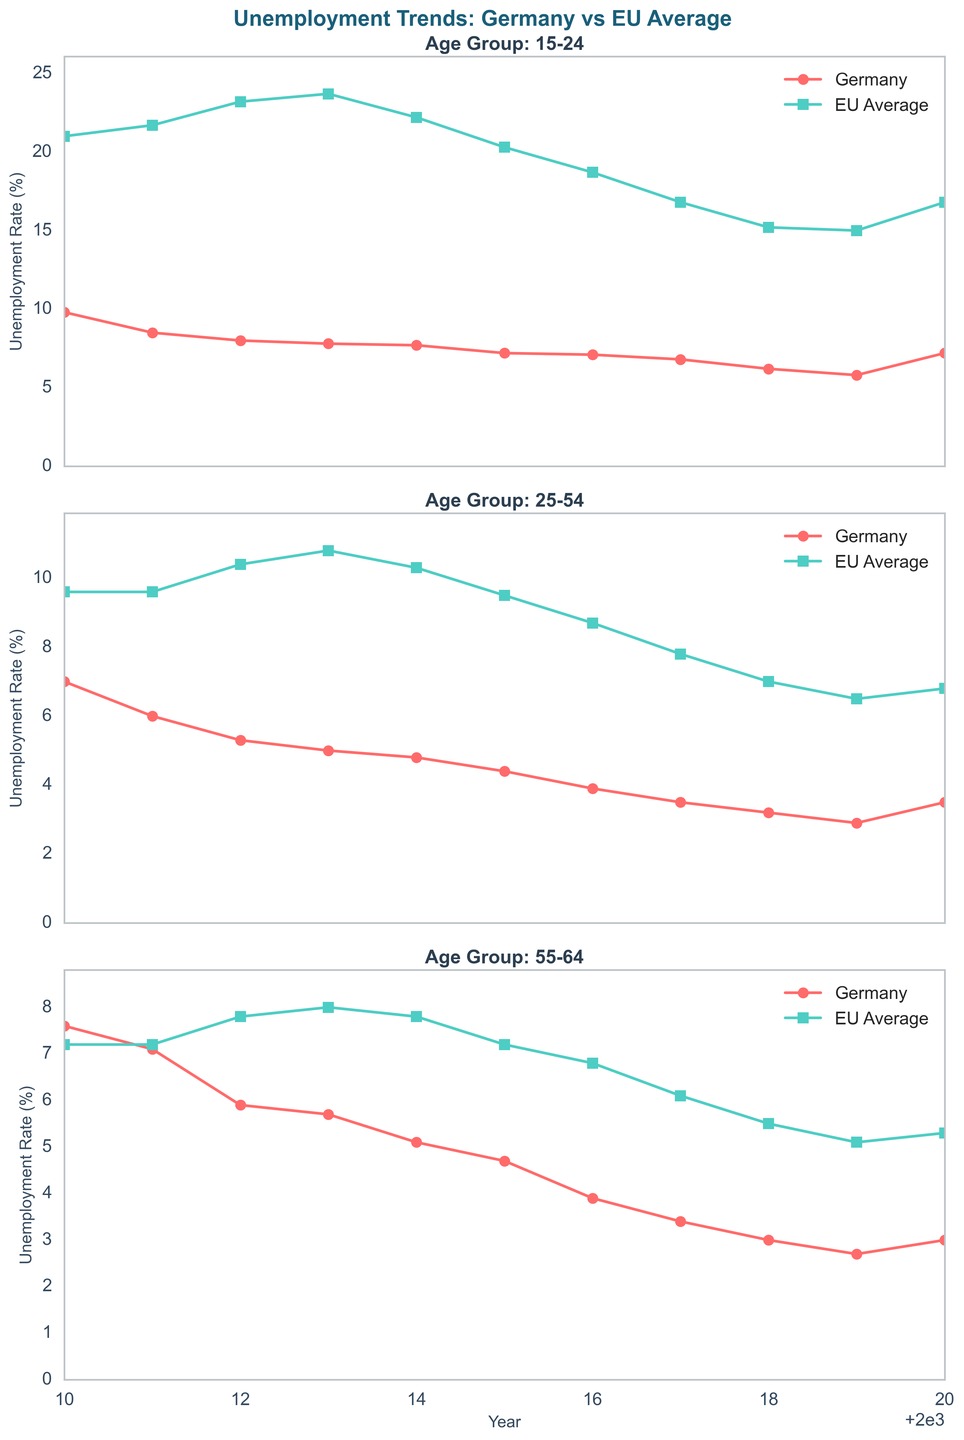What was the difference in unemployment rates for the 15-24 age group between Germany and the EU Average in 2012? In 2012, the unemployment rate for the 15-24 age group in Germany was 8.0%, while for the EU average, it was 23.2%. The difference is calculated as 23.2% - 8.0% = 15.2%.
Answer: 15.2% Which age group in Germany had the highest unemployment rate in 2010, and what was that rate? In 2010, among the three age groups (15-24, 25-54, 55-64) in Germany, the 15-24 age group had the highest unemployment rate at 9.8%.
Answer: 15-24, 9.8% How did the trend in unemployment rates for the 25-54 age group in Germany compare to the EU average from 2010 to 2020? The unemployment rate for the 25-54 age group in Germany consistently decreased from 7.0% in 2010 to 3.5% in 2020. In contrast, the EU average unemployment rate for the same age group decreased from 9.6% in 2010 to 6.8% in 2020, but the decrease was less pronounced compared to Germany.
Answer: German rate decreased more sharply Which year showed the smallest difference in unemployment rates between Germany and the EU average for the 55-64 age group? Looking at the data for the 55-64 age group, the smallest difference between Germany and the EU average was in 2010, with Germany at 7.6% and the EU average at 7.2%, giving a difference of 0.4%.
Answer: 2010 What is the average unemployment rate for the 15-24 age group in Germany over the period 2010-2020? To find the average, sum the unemployment rates for the 15-24 age group in Germany from 2010 to 2020 and then divide by the number of years. This is (9.8 + 8.5 + 8.0 + 7.8 + 7.7 + 7.2 + 7.1 + 6.8 + 6.2 + 5.8 + 7.2) / 11 = 7.482%.
Answer: 7.48% Did the 55-64 age group in Germany ever have a lower unemployment rate than the EU average? If so, in which year(s)? By comparing the data, the 55-64 age group in Germany had a lower unemployment rate than the EU average from 2015 to 2020.
Answer: 2015 to 2020 Between 2011 and 2013, which age group in Germany saw the largest decrease in unemployment rate? The 25-54 age group in Germany saw the largest decrease in unemployment rate between 2011 and 2013, decreasing from 6.0% to 5.0%, a decrease of 1.0%.
Answer: 25-54 What was the trend for the EU average unemployment rate for the 25-54 age group from 2010 to 2019? The EU average unemployment rate for the 25-54 age group decreased from 9.6% in 2010 to 6.5% in 2019, showing a general downward trend over the period.
Answer: Decreasing trend Was there any year in which all age groups in Germany had lower unemployment rates than their EU counterparts? In 2019, all age groups in Germany had lower unemployment rates than their EU counterparts: 15-24 (5.8% vs 15.0%), 25-54 (2.9% vs 6.5%), and 55-64 (2.7% vs 5.1%).
Answer: 2019 